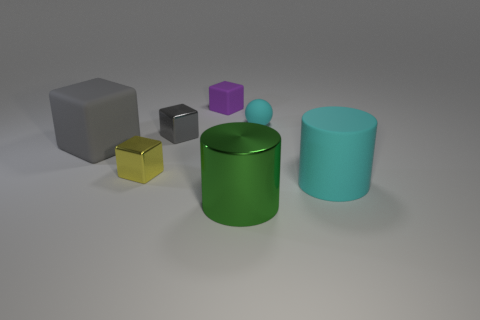Do the ball and the matte cylinder have the same color?
Give a very brief answer. Yes. What material is the cylinder that is the same color as the tiny matte sphere?
Offer a very short reply. Rubber. What size is the thing that is the same color as the sphere?
Your response must be concise. Large. What is the big cyan thing made of?
Keep it short and to the point. Rubber. Are the yellow thing and the big cylinder that is left of the cyan cylinder made of the same material?
Ensure brevity in your answer.  Yes. There is a cylinder that is right of the shiny object right of the tiny gray metal thing; what color is it?
Your answer should be very brief. Cyan. There is a rubber object that is both in front of the rubber sphere and on the left side of the large green shiny thing; what size is it?
Provide a succinct answer. Large. How many other things are the same shape as the tiny cyan thing?
Make the answer very short. 0. There is a big metal object; is its shape the same as the cyan thing in front of the yellow object?
Make the answer very short. Yes. There is a small purple object; what number of small balls are behind it?
Make the answer very short. 0. 